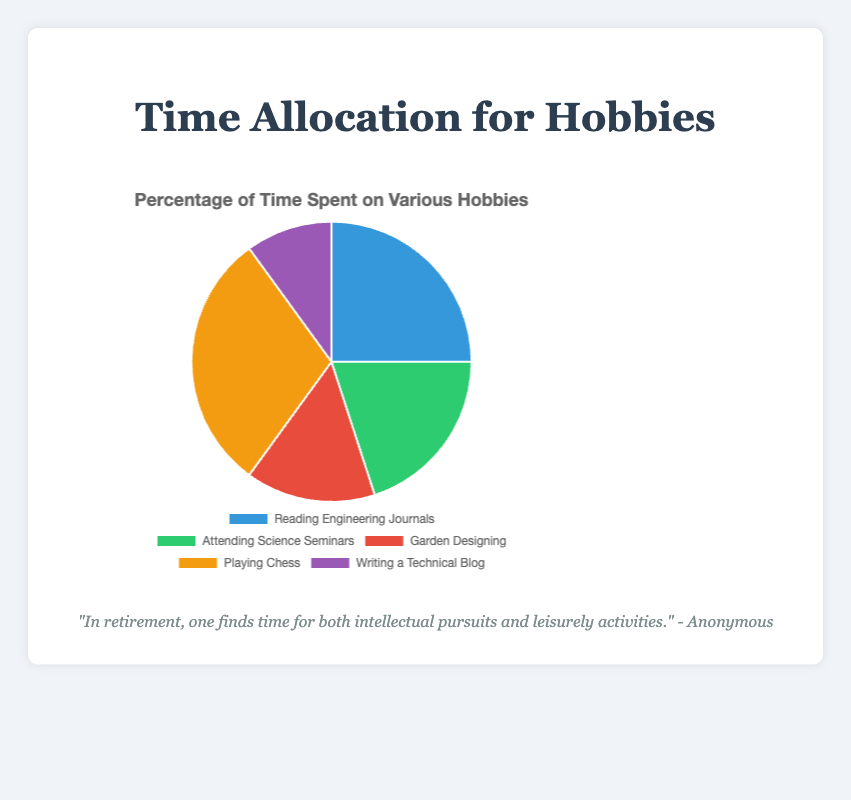What's the activity with the highest percentage of time allocation? The largest percentage slice in the pie chart represents the activity to which the most time is allocated. Looking at the figures: Reading Engineering Journals (25%), Attending Science Seminars (20%), Garden Designing (15%), Playing Chess (30%), Writing a Technical Blog (10%), we see that Playing Chess has the highest percentage.
Answer: Playing Chess Which activity combines for 35% of the time spent when together with Reading Engineering Journals? The two activities' percentages are summed to get the combined allocation. Reading Engineering Journals comprises 25% and Writing a Technical Blog comprises 10%, totaling 25% + 10% = 35%.
Answer: Reading Engineering Journals and Writing a Technical Blog How much more time is spent on Playing Chess compared to Garden Designing? The difference between the percentages allocated to these two activities is calculated. Playing Chess is 30% and Garden Designing is 15%. The difference is 30% - 15% = 15%.
Answer: 15% What is the median percentage value of the activities? To find the median, the activities' percentages are ordered (10%, 15%, 20%, 25%, 30%) and the middle value is selected. With an odd number of values (5), the median is the third value in the ordered list.
Answer: 20% Which activities together account for half of the total time allocation? Starting from the highest percentage and summing until reaching or exceeding 50%, we get Playing Chess (30%) + Reading Engineering Journals (25%) = 55%.
Answer: Playing Chess and Reading Engineering Journals How much less time is spent on Writing a Technical Blog compared to Attending Science Seminars? Subtract the lower percentage from the higher percentage. Attending Science Seminars is 20% and Writing a Technical Blog is 10%. Therefore, 20% - 10% = 10%.
Answer: 10% What percentage is allocated to activities that are not intellectually focused? Identify non-intellectual activities and sum their percentages. Garden Designing (15%) and Playing Chess (30%) are not primarily intellectual, so 15% + 30% = 45%.
Answer: 45% Which activity's time allocation is closest to the allocation for Garden Designing? Compare Garden Designing's percentage (15%) with the other activities: Reading Engineering Journals (25%), Attending Science Seminars (20%), Playing Chess (30%), Writing a Technical Blog (10%). The closest in value is Writing a Technical Blog with 10%.
Answer: Writing a Technical Blog What's the total percentage of time spent on Reading Engineering Journals and Attending Science Seminars? Summing the percentages for Reading Engineering Journals (25%) and Attending Science Seminars (20%) results in 25% + 20% = 45%.
Answer: 45% 